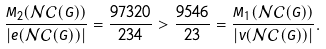Convert formula to latex. <formula><loc_0><loc_0><loc_500><loc_500>\frac { M _ { 2 } ( \mathcal { N C } ( G ) ) } { | e ( \mathcal { N C } ( G ) ) | } = \frac { 9 7 3 2 0 } { 2 3 4 } > \frac { 9 5 4 6 } { 2 3 } = \frac { M _ { 1 } ( \mathcal { N C } ( G ) ) } { | v ( \mathcal { N C } ( G ) ) | } .</formula> 